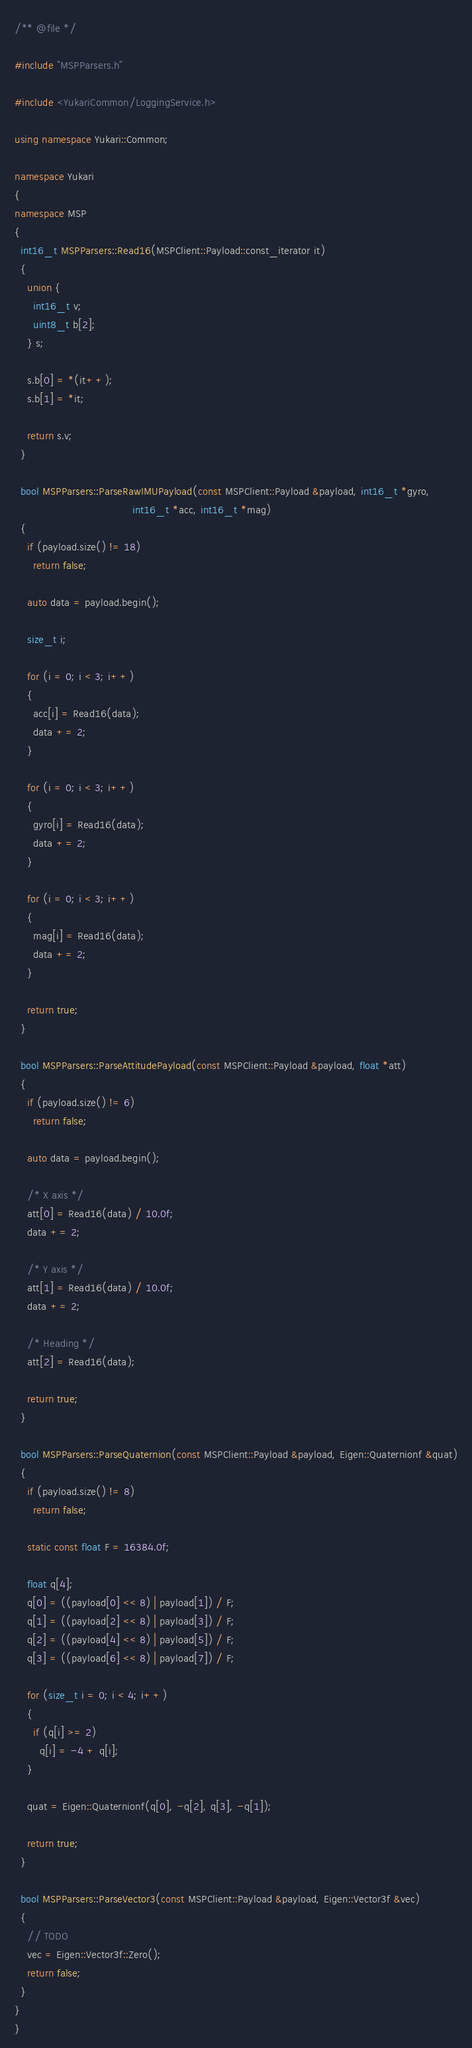<code> <loc_0><loc_0><loc_500><loc_500><_C++_>/** @file */

#include "MSPParsers.h"

#include <YukariCommon/LoggingService.h>

using namespace Yukari::Common;

namespace Yukari
{
namespace MSP
{
  int16_t MSPParsers::Read16(MSPClient::Payload::const_iterator it)
  {
    union {
      int16_t v;
      uint8_t b[2];
    } s;

    s.b[0] = *(it++);
    s.b[1] = *it;

    return s.v;
  }

  bool MSPParsers::ParseRawIMUPayload(const MSPClient::Payload &payload, int16_t *gyro,
                                      int16_t *acc, int16_t *mag)
  {
    if (payload.size() != 18)
      return false;

    auto data = payload.begin();

    size_t i;

    for (i = 0; i < 3; i++)
    {
      acc[i] = Read16(data);
      data += 2;
    }

    for (i = 0; i < 3; i++)
    {
      gyro[i] = Read16(data);
      data += 2;
    }

    for (i = 0; i < 3; i++)
    {
      mag[i] = Read16(data);
      data += 2;
    }

    return true;
  }

  bool MSPParsers::ParseAttitudePayload(const MSPClient::Payload &payload, float *att)
  {
    if (payload.size() != 6)
      return false;

    auto data = payload.begin();

    /* X axis */
    att[0] = Read16(data) / 10.0f;
    data += 2;

    /* Y axis */
    att[1] = Read16(data) / 10.0f;
    data += 2;

    /* Heading */
    att[2] = Read16(data);

    return true;
  }

  bool MSPParsers::ParseQuaternion(const MSPClient::Payload &payload, Eigen::Quaternionf &quat)
  {
    if (payload.size() != 8)
      return false;

    static const float F = 16384.0f;

    float q[4];
    q[0] = ((payload[0] << 8) | payload[1]) / F;
    q[1] = ((payload[2] << 8) | payload[3]) / F;
    q[2] = ((payload[4] << 8) | payload[5]) / F;
    q[3] = ((payload[6] << 8) | payload[7]) / F;

    for (size_t i = 0; i < 4; i++)
    {
      if (q[i] >= 2)
        q[i] = -4 + q[i];
    }

    quat = Eigen::Quaternionf(q[0], -q[2], q[3], -q[1]);

    return true;
  }

  bool MSPParsers::ParseVector3(const MSPClient::Payload &payload, Eigen::Vector3f &vec)
  {
    // TODO
    vec = Eigen::Vector3f::Zero();
    return false;
  }
}
}
</code> 